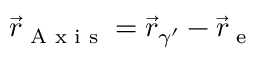<formula> <loc_0><loc_0><loc_500><loc_500>\vec { r } _ { A x i s } = \vec { r } _ { \gamma ^ { \prime } } - \vec { r } _ { e }</formula> 